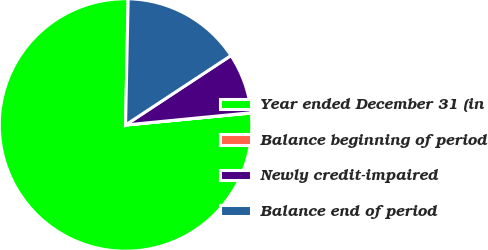Convert chart to OTSL. <chart><loc_0><loc_0><loc_500><loc_500><pie_chart><fcel>Year ended December 31 (in<fcel>Balance beginning of period<fcel>Newly credit-impaired<fcel>Balance end of period<nl><fcel>76.84%<fcel>0.04%<fcel>7.72%<fcel>15.4%<nl></chart> 